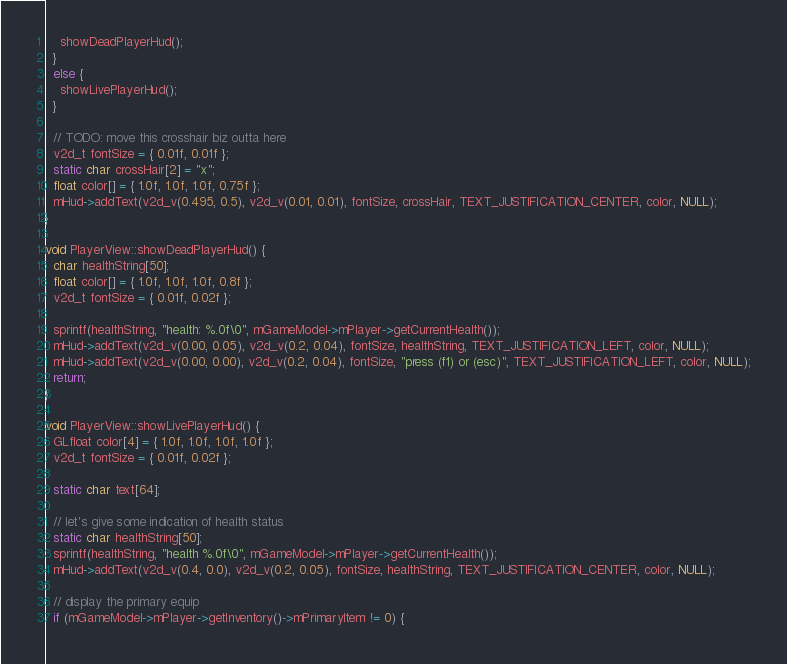<code> <loc_0><loc_0><loc_500><loc_500><_C++_>    showDeadPlayerHud();
  }
  else {
    showLivePlayerHud();
  }

  // TODO: move this crosshair biz outta here
  v2d_t fontSize = { 0.01f, 0.01f };
  static char crossHair[2] = "x";
  float color[] = { 1.0f, 1.0f, 1.0f, 0.75f };
  mHud->addText(v2d_v(0.495, 0.5), v2d_v(0.01, 0.01), fontSize, crossHair, TEXT_JUSTIFICATION_CENTER, color, NULL);
}

void PlayerView::showDeadPlayerHud() {
  char healthString[50];
  float color[] = { 1.0f, 1.0f, 1.0f, 0.8f };
  v2d_t fontSize = { 0.01f, 0.02f };

  sprintf(healthString, "health: %.0f\0", mGameModel->mPlayer->getCurrentHealth());
  mHud->addText(v2d_v(0.00, 0.05), v2d_v(0.2, 0.04), fontSize, healthString, TEXT_JUSTIFICATION_LEFT, color, NULL);
  mHud->addText(v2d_v(0.00, 0.00), v2d_v(0.2, 0.04), fontSize, "press (f1) or (esc)", TEXT_JUSTIFICATION_LEFT, color, NULL);
  return;
}

void PlayerView::showLivePlayerHud() {
  GLfloat color[4] = { 1.0f, 1.0f, 1.0f, 1.0f };
  v2d_t fontSize = { 0.01f, 0.02f };

  static char text[64];

  // let's give some indication of health status
  static char healthString[50];
  sprintf(healthString, "health %.0f\0", mGameModel->mPlayer->getCurrentHealth());
  mHud->addText(v2d_v(0.4, 0.0), v2d_v(0.2, 0.05), fontSize, healthString, TEXT_JUSTIFICATION_CENTER, color, NULL);

  // display the primary equip
  if (mGameModel->mPlayer->getInventory()->mPrimaryItem != 0) {</code> 